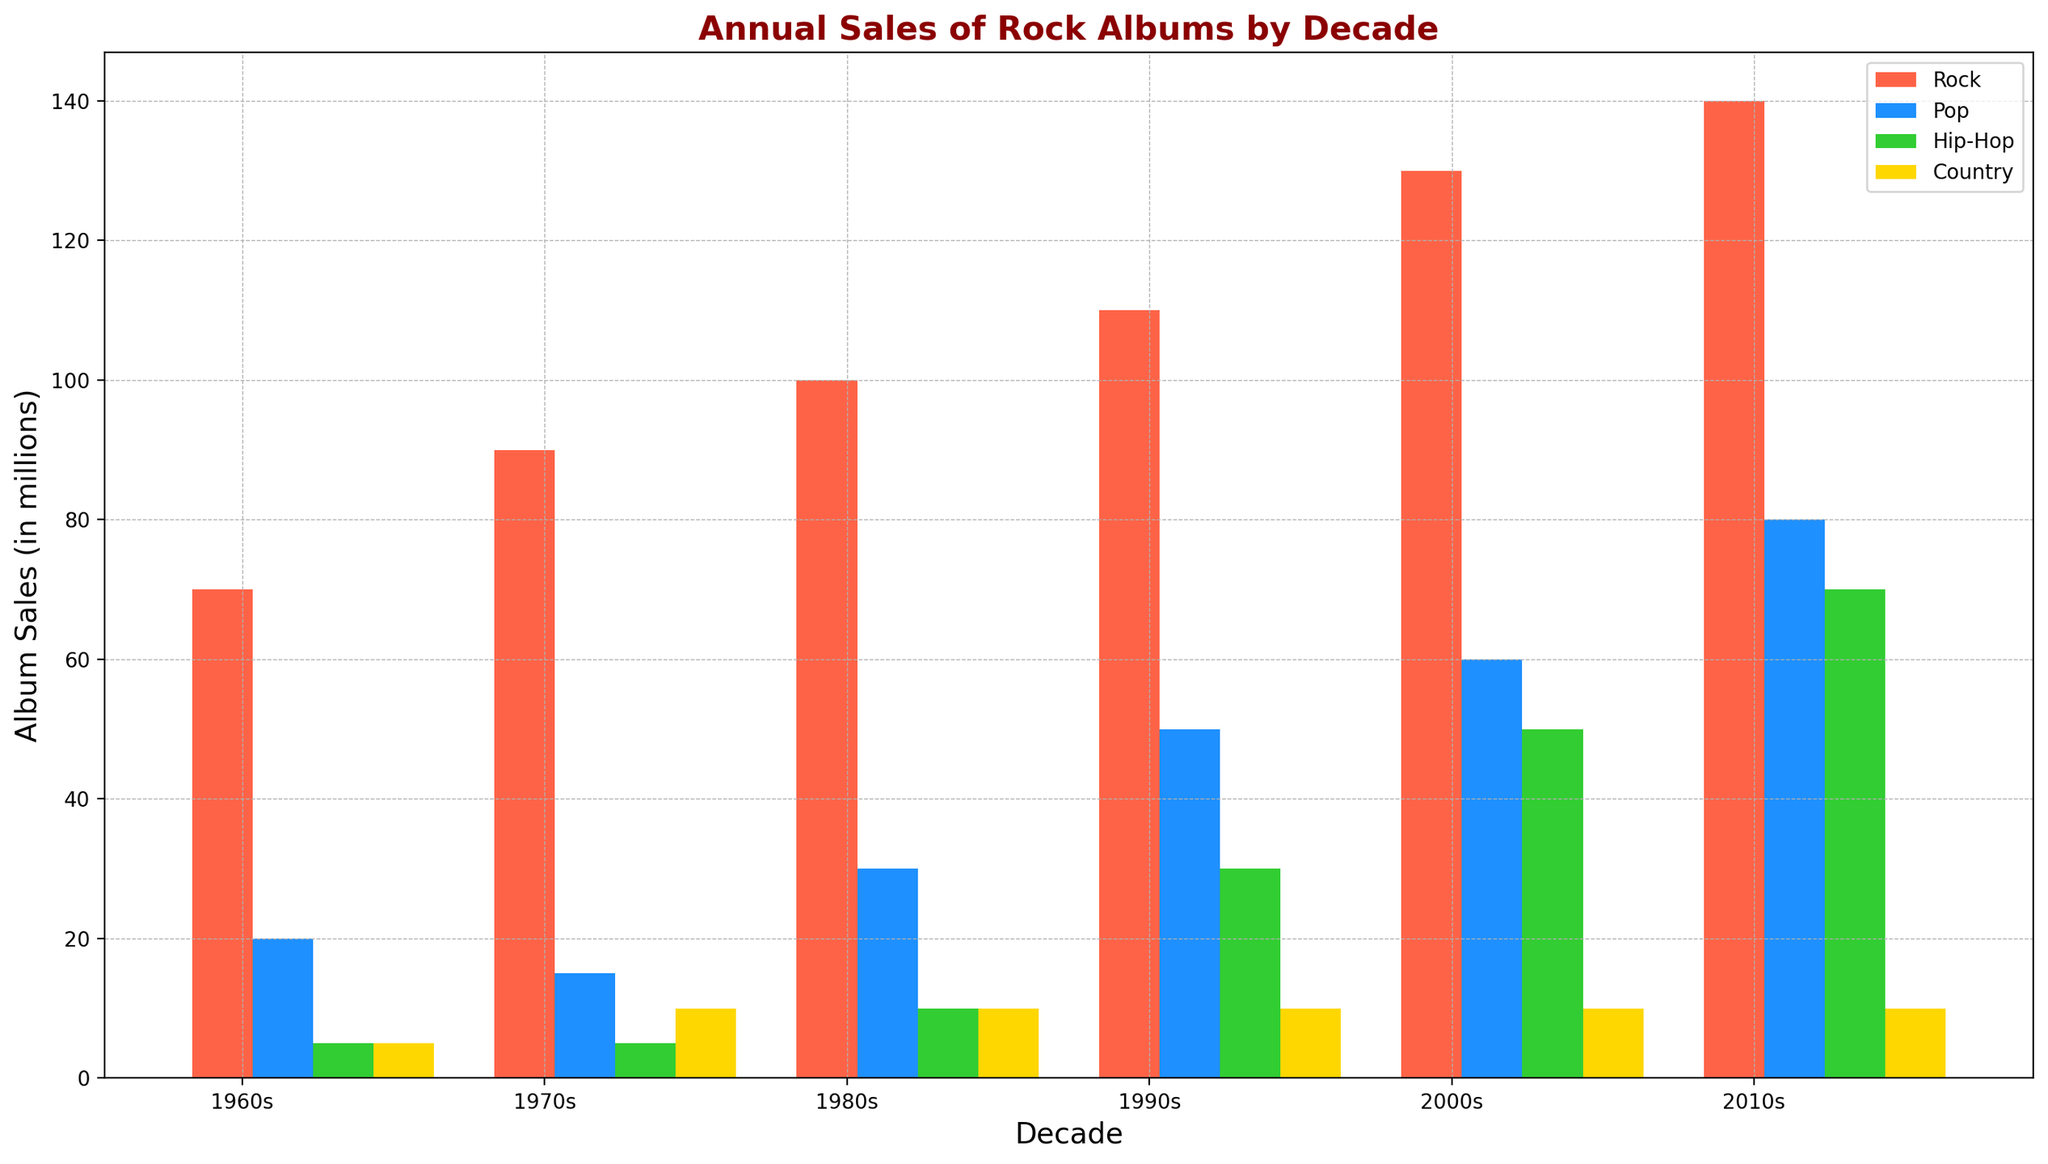Which decade had the highest annual sales of rock albums? Look at the bars representing rock album sales for each decade. The tallest bar indicates the highest sales. The bar for the 2010s is the tallest.
Answer: 2010s How much more were the rock album sales in the 2000s compared to the 1970s? Find the height of the rock album bars for both the 2000s and the 1970s. Subtract the 1970s sales (90 million) from the 2000s sales (130 million).
Answer: 40 million What is the total sales of rock albums over all decades? Sum the rock album sales for each decade: 70+90+100+110+130+140.
Answer: 640 million How do pop album sales in the 1980s compare to pop album sales in the 2010s? Compare the height of the pop album bars for the 1980s (30 million) and the 2010s (80 million). The 2010s have higher sales.
Answer: 2010s have higher sales Which genre had the least variation in sales across all decades? Observe the bars of each genre across the decades and check which has the most similar heights. Country album sales (5, 10, 10, 10, 10, 10) have the least variation.
Answer: Country In which decades did hip-hop album sales experience a significant increase? Look for large increases in the height of the hip-hop bars. Sales increased significantly from the 1980s (10 million) to the 1990s (30 million) and again from the 2000s (50 million) to the 2010s (70 million).
Answer: 1990s, 2010s What is the average annual sales of rock albums in the 1990s and 2000s combined? Sum the rock album sales in these decades (110 + 130) and divide by 2.
Answer: 120 million What is the combined rock album sales for the 1960s and 1970s? Add the rock album sales of the 1960s (70 million) and the 1970s (90 million).
Answer: 160 million Which genre showed the highest increase in sales from the 1960s to the 2010s? Compare the sales for each genre from the 1960s to the 2010s and identify the highest difference. Rock increased from 70 million to 140 million (an increase of 70 million).
Answer: Rock What is the difference in sales between the highest and lowest selling decades for rock albums? Identify the highest (140 million in the 2010s) and the lowest (70 million in the 1960s) sales and subtract the lowest from the highest.
Answer: 70 million 